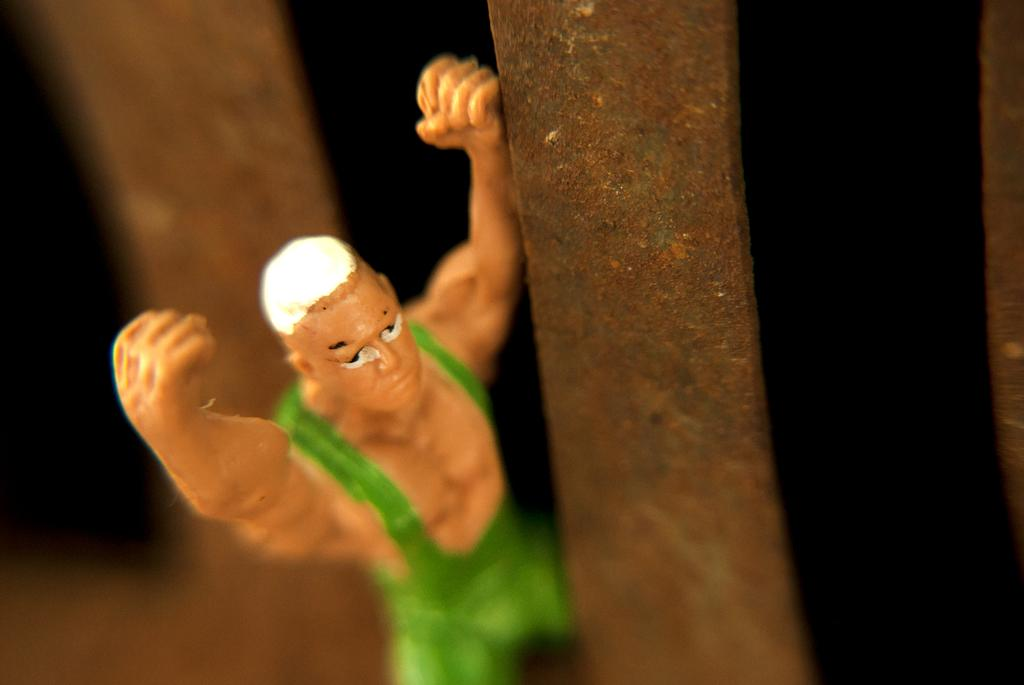What object is the main focus of the image? There is a toy in the image. Can you describe the background of the image? The background of the image is dark and blurred. What type of calculator is being used for the observation in the image? There is no calculator or observation present in the image; it features a toy with a dark and blurred background. 